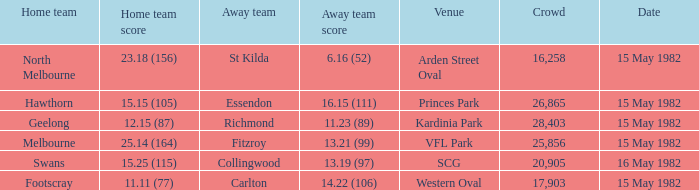Which away team had more than 17,903 spectators and played Melbourne? 13.21 (99). 